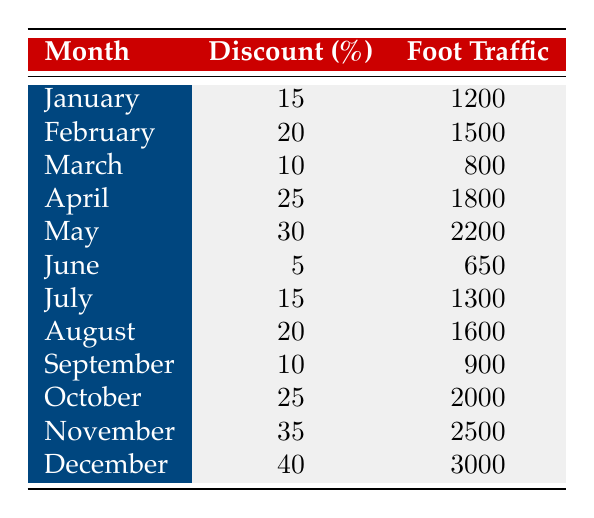What was the customer foot traffic in December? According to the table, the customer foot traffic for December is listed directly.
Answer: 3000 What discount percentage was offered in April? In the table, the discount percentage for April is specified clearly.
Answer: 25 Which month had the highest customer foot traffic? By examining the customer foot traffic values in the table, December shows the highest number.
Answer: December What is the average discount percentage across all months? To find the average, add all the discount percentages (15 + 20 + 10 + 25 + 30 + 5 + 15 + 20 + 10 + 25 + 35 + 40 =  300) and divide by the number of months (12), which results in 300/12 = 25.
Answer: 25 Is the foot traffic in March more than the foot traffic in June? By comparing the values, March has 800 while June has 650, therefore, March has more foot traffic than June.
Answer: Yes In which month did the foot traffic reach 1800? The table indicates that 1800 foot traffic occurred in April.
Answer: April What is the difference in foot traffic between November and January? The table shows November foot traffic as 2500 and January as 1200. The difference is calculated as 2500 - 1200 = 1300.
Answer: 1300 Was there a month where the discount percentage was less than 10? Looking through the discount percentages, the minimum is 5 in June, which is less than 10.
Answer: Yes Which month had both the highest discount percentage and customer foot traffic? December had the highest discount of 40% and the highest foot traffic of 3000, making it the month with both highest values.
Answer: December 